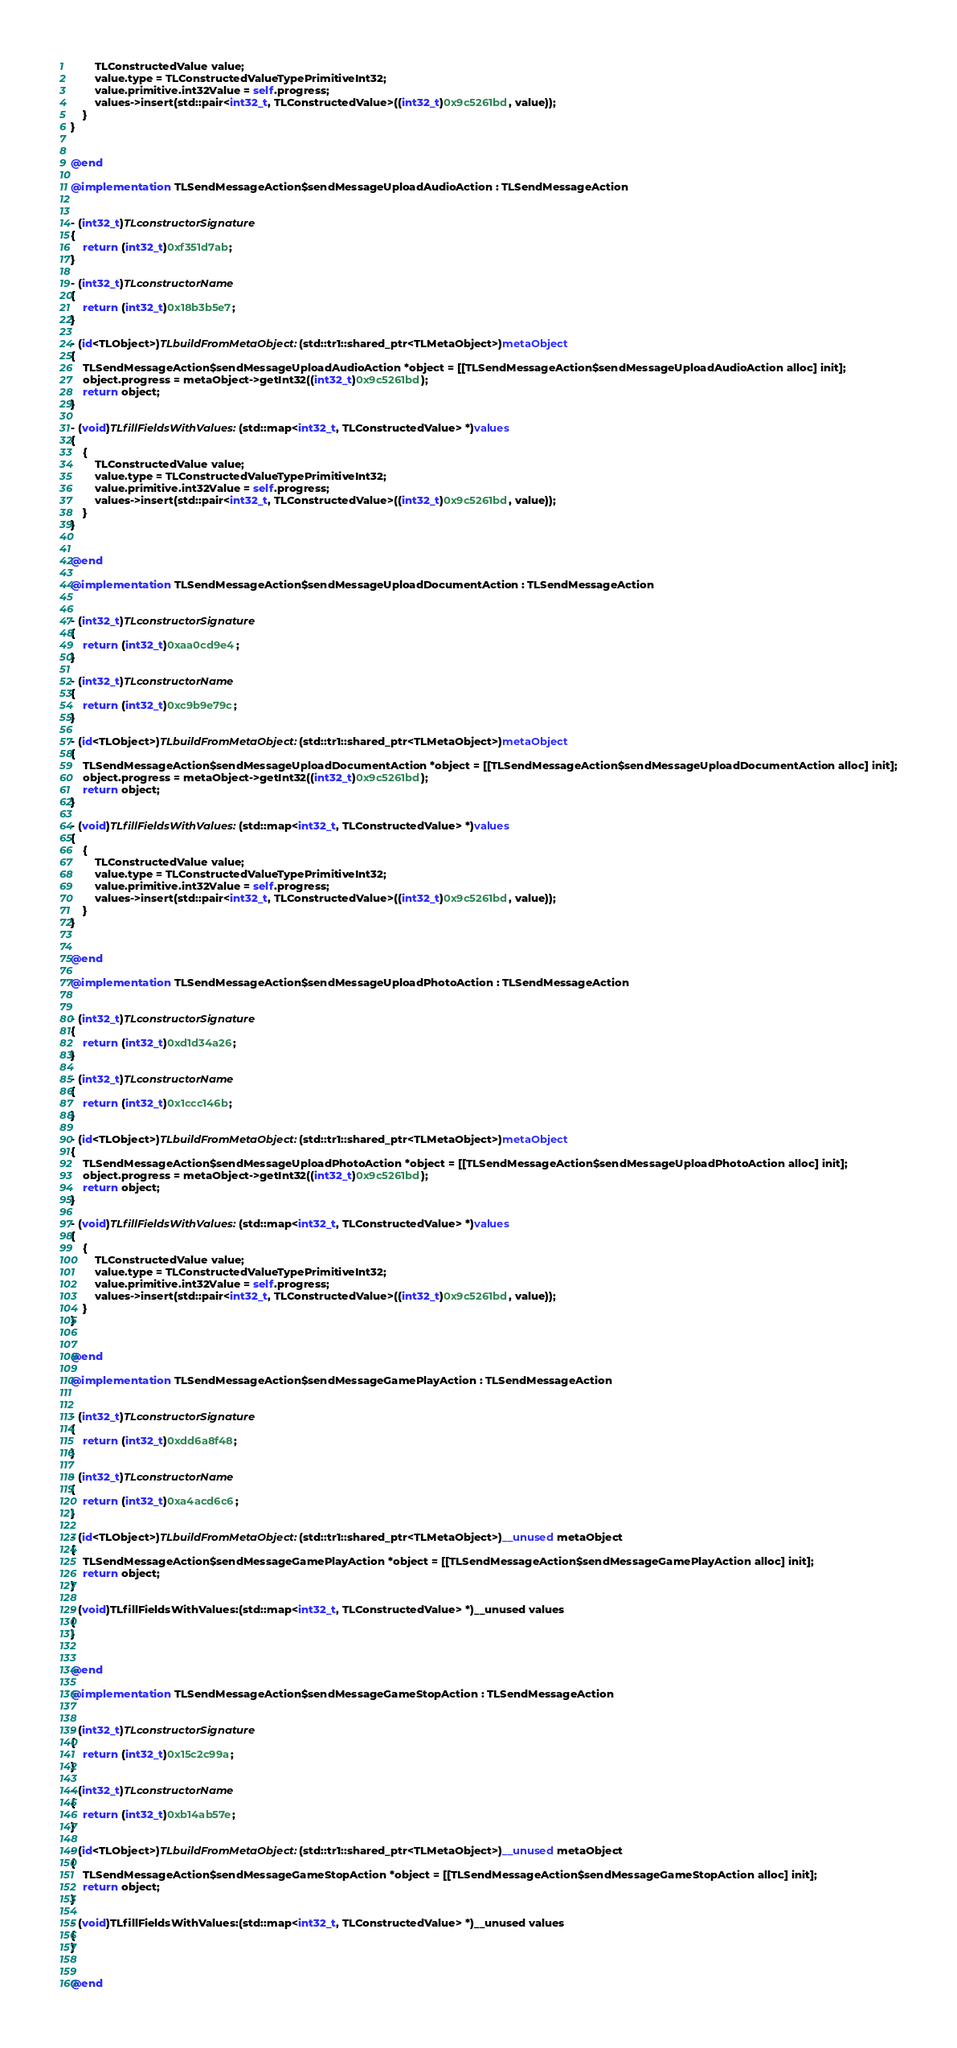Convert code to text. <code><loc_0><loc_0><loc_500><loc_500><_ObjectiveC_>        TLConstructedValue value;
        value.type = TLConstructedValueTypePrimitiveInt32;
        value.primitive.int32Value = self.progress;
        values->insert(std::pair<int32_t, TLConstructedValue>((int32_t)0x9c5261bd, value));
    }
}


@end

@implementation TLSendMessageAction$sendMessageUploadAudioAction : TLSendMessageAction


- (int32_t)TLconstructorSignature
{
    return (int32_t)0xf351d7ab;
}

- (int32_t)TLconstructorName
{
    return (int32_t)0x18b3b5e7;
}

- (id<TLObject>)TLbuildFromMetaObject:(std::tr1::shared_ptr<TLMetaObject>)metaObject
{
    TLSendMessageAction$sendMessageUploadAudioAction *object = [[TLSendMessageAction$sendMessageUploadAudioAction alloc] init];
    object.progress = metaObject->getInt32((int32_t)0x9c5261bd);
    return object;
}

- (void)TLfillFieldsWithValues:(std::map<int32_t, TLConstructedValue> *)values
{
    {
        TLConstructedValue value;
        value.type = TLConstructedValueTypePrimitiveInt32;
        value.primitive.int32Value = self.progress;
        values->insert(std::pair<int32_t, TLConstructedValue>((int32_t)0x9c5261bd, value));
    }
}


@end

@implementation TLSendMessageAction$sendMessageUploadDocumentAction : TLSendMessageAction


- (int32_t)TLconstructorSignature
{
    return (int32_t)0xaa0cd9e4;
}

- (int32_t)TLconstructorName
{
    return (int32_t)0xc9b9e79c;
}

- (id<TLObject>)TLbuildFromMetaObject:(std::tr1::shared_ptr<TLMetaObject>)metaObject
{
    TLSendMessageAction$sendMessageUploadDocumentAction *object = [[TLSendMessageAction$sendMessageUploadDocumentAction alloc] init];
    object.progress = metaObject->getInt32((int32_t)0x9c5261bd);
    return object;
}

- (void)TLfillFieldsWithValues:(std::map<int32_t, TLConstructedValue> *)values
{
    {
        TLConstructedValue value;
        value.type = TLConstructedValueTypePrimitiveInt32;
        value.primitive.int32Value = self.progress;
        values->insert(std::pair<int32_t, TLConstructedValue>((int32_t)0x9c5261bd, value));
    }
}


@end

@implementation TLSendMessageAction$sendMessageUploadPhotoAction : TLSendMessageAction


- (int32_t)TLconstructorSignature
{
    return (int32_t)0xd1d34a26;
}

- (int32_t)TLconstructorName
{
    return (int32_t)0x1ccc146b;
}

- (id<TLObject>)TLbuildFromMetaObject:(std::tr1::shared_ptr<TLMetaObject>)metaObject
{
    TLSendMessageAction$sendMessageUploadPhotoAction *object = [[TLSendMessageAction$sendMessageUploadPhotoAction alloc] init];
    object.progress = metaObject->getInt32((int32_t)0x9c5261bd);
    return object;
}

- (void)TLfillFieldsWithValues:(std::map<int32_t, TLConstructedValue> *)values
{
    {
        TLConstructedValue value;
        value.type = TLConstructedValueTypePrimitiveInt32;
        value.primitive.int32Value = self.progress;
        values->insert(std::pair<int32_t, TLConstructedValue>((int32_t)0x9c5261bd, value));
    }
}


@end

@implementation TLSendMessageAction$sendMessageGamePlayAction : TLSendMessageAction


- (int32_t)TLconstructorSignature
{
    return (int32_t)0xdd6a8f48;
}

- (int32_t)TLconstructorName
{
    return (int32_t)0xa4acd6c6;
}

- (id<TLObject>)TLbuildFromMetaObject:(std::tr1::shared_ptr<TLMetaObject>)__unused metaObject
{
    TLSendMessageAction$sendMessageGamePlayAction *object = [[TLSendMessageAction$sendMessageGamePlayAction alloc] init];
    return object;
}

- (void)TLfillFieldsWithValues:(std::map<int32_t, TLConstructedValue> *)__unused values
{
}


@end

@implementation TLSendMessageAction$sendMessageGameStopAction : TLSendMessageAction


- (int32_t)TLconstructorSignature
{
    return (int32_t)0x15c2c99a;
}

- (int32_t)TLconstructorName
{
    return (int32_t)0xb14ab57e;
}

- (id<TLObject>)TLbuildFromMetaObject:(std::tr1::shared_ptr<TLMetaObject>)__unused metaObject
{
    TLSendMessageAction$sendMessageGameStopAction *object = [[TLSendMessageAction$sendMessageGameStopAction alloc] init];
    return object;
}

- (void)TLfillFieldsWithValues:(std::map<int32_t, TLConstructedValue> *)__unused values
{
}


@end

</code> 